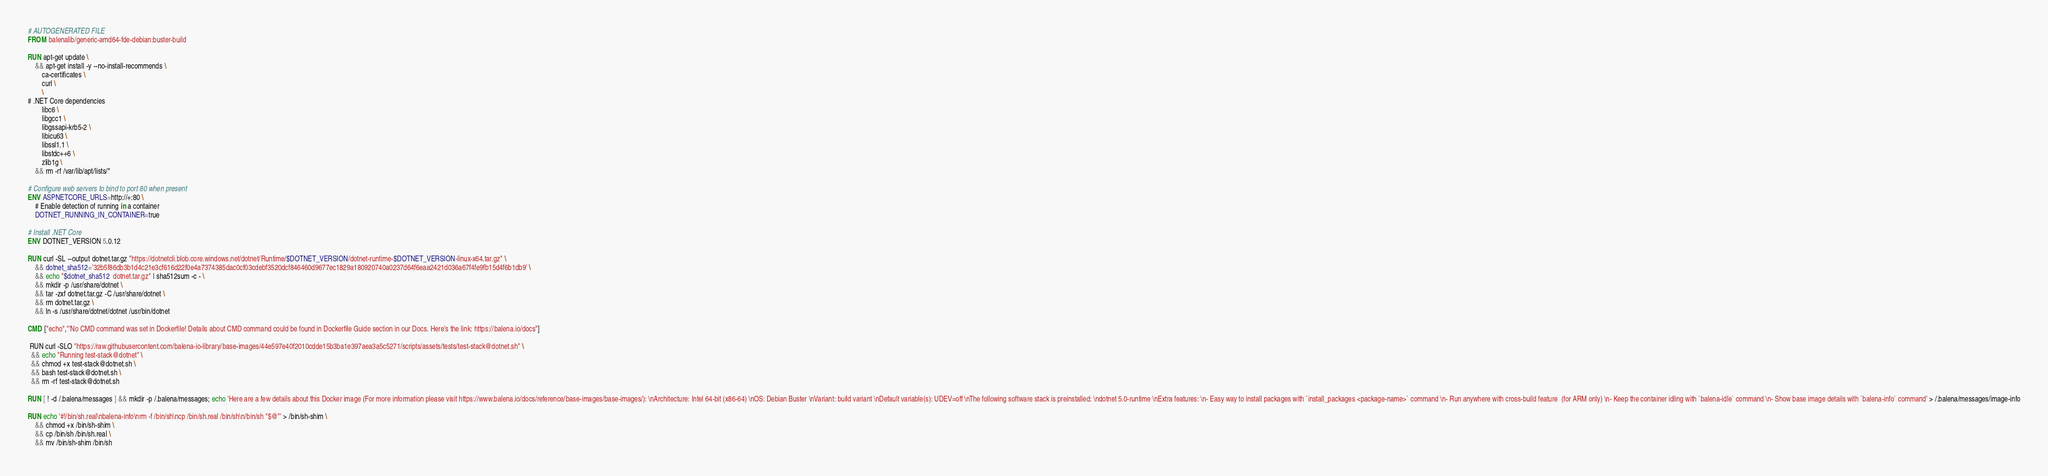<code> <loc_0><loc_0><loc_500><loc_500><_Dockerfile_># AUTOGENERATED FILE
FROM balenalib/generic-amd64-fde-debian:buster-build

RUN apt-get update \
    && apt-get install -y --no-install-recommends \
        ca-certificates \
        curl \
        \
# .NET Core dependencies
        libc6 \
        libgcc1 \
        libgssapi-krb5-2 \
        libicu63 \
        libssl1.1 \
        libstdc++6 \
        zlib1g \
    && rm -rf /var/lib/apt/lists/*

# Configure web servers to bind to port 80 when present
ENV ASPNETCORE_URLS=http://+:80 \
    # Enable detection of running in a container
    DOTNET_RUNNING_IN_CONTAINER=true

# Install .NET Core
ENV DOTNET_VERSION 5.0.12

RUN curl -SL --output dotnet.tar.gz "https://dotnetcli.blob.core.windows.net/dotnet/Runtime/$DOTNET_VERSION/dotnet-runtime-$DOTNET_VERSION-linux-x64.tar.gz" \
    && dotnet_sha512='32b5f86db3b1d4c21e3cf616d22f0e4a7374385dac0cf03cdebf3520dcf846460d9677ec1829a180920740a0237d64f6eaa2421d036a67f4fe9fb15d4f6b1db9' \
    && echo "$dotnet_sha512  dotnet.tar.gz" | sha512sum -c - \
    && mkdir -p /usr/share/dotnet \
    && tar -zxf dotnet.tar.gz -C /usr/share/dotnet \
    && rm dotnet.tar.gz \
    && ln -s /usr/share/dotnet/dotnet /usr/bin/dotnet

CMD ["echo","'No CMD command was set in Dockerfile! Details about CMD command could be found in Dockerfile Guide section in our Docs. Here's the link: https://balena.io/docs"]

 RUN curl -SLO "https://raw.githubusercontent.com/balena-io-library/base-images/44e597e40f2010cdde15b3ba1e397aea3a5c5271/scripts/assets/tests/test-stack@dotnet.sh" \
  && echo "Running test-stack@dotnet" \
  && chmod +x test-stack@dotnet.sh \
  && bash test-stack@dotnet.sh \
  && rm -rf test-stack@dotnet.sh 

RUN [ ! -d /.balena/messages ] && mkdir -p /.balena/messages; echo 'Here are a few details about this Docker image (For more information please visit https://www.balena.io/docs/reference/base-images/base-images/): \nArchitecture: Intel 64-bit (x86-64) \nOS: Debian Buster \nVariant: build variant \nDefault variable(s): UDEV=off \nThe following software stack is preinstalled: \ndotnet 5.0-runtime \nExtra features: \n- Easy way to install packages with `install_packages <package-name>` command \n- Run anywhere with cross-build feature  (for ARM only) \n- Keep the container idling with `balena-idle` command \n- Show base image details with `balena-info` command' > /.balena/messages/image-info

RUN echo '#!/bin/sh.real\nbalena-info\nrm -f /bin/sh\ncp /bin/sh.real /bin/sh\n/bin/sh "$@"' > /bin/sh-shim \
	&& chmod +x /bin/sh-shim \
	&& cp /bin/sh /bin/sh.real \
	&& mv /bin/sh-shim /bin/sh</code> 